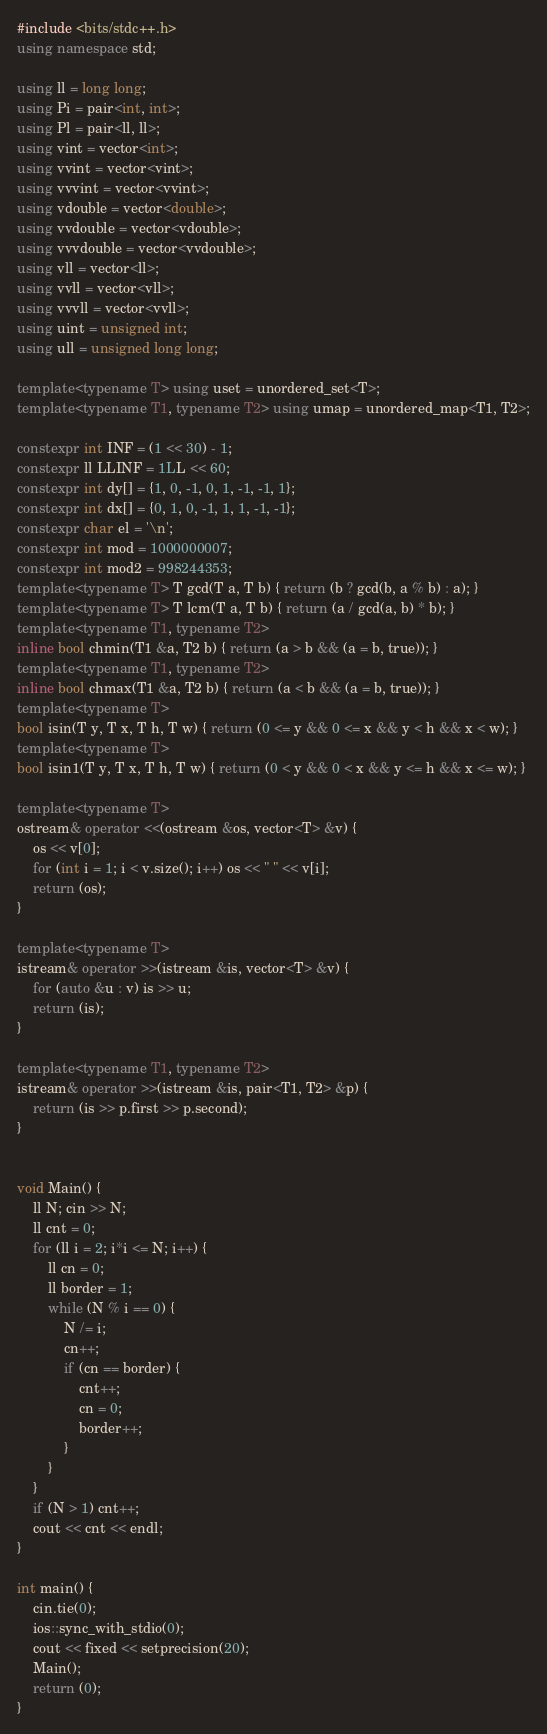<code> <loc_0><loc_0><loc_500><loc_500><_C++_>#include <bits/stdc++.h>
using namespace std;

using ll = long long;
using Pi = pair<int, int>;
using Pl = pair<ll, ll>;
using vint = vector<int>;
using vvint = vector<vint>;
using vvvint = vector<vvint>;
using vdouble = vector<double>;
using vvdouble = vector<vdouble>;
using vvvdouble = vector<vvdouble>;
using vll = vector<ll>;
using vvll = vector<vll>;
using vvvll = vector<vvll>;
using uint = unsigned int;
using ull = unsigned long long;

template<typename T> using uset = unordered_set<T>;
template<typename T1, typename T2> using umap = unordered_map<T1, T2>;

constexpr int INF = (1 << 30) - 1;
constexpr ll LLINF = 1LL << 60;
constexpr int dy[] = {1, 0, -1, 0, 1, -1, -1, 1};
constexpr int dx[] = {0, 1, 0, -1, 1, 1, -1, -1};
constexpr char el = '\n';
constexpr int mod = 1000000007;
constexpr int mod2 = 998244353;
template<typename T> T gcd(T a, T b) { return (b ? gcd(b, a % b) : a); }
template<typename T> T lcm(T a, T b) { return (a / gcd(a, b) * b); }
template<typename T1, typename T2>
inline bool chmin(T1 &a, T2 b) { return (a > b && (a = b, true)); }
template<typename T1, typename T2>
inline bool chmax(T1 &a, T2 b) { return (a < b && (a = b, true)); }
template<typename T>
bool isin(T y, T x, T h, T w) { return (0 <= y && 0 <= x && y < h && x < w); }
template<typename T>
bool isin1(T y, T x, T h, T w) { return (0 < y && 0 < x && y <= h && x <= w); }

template<typename T>
ostream& operator <<(ostream &os, vector<T> &v) {
	os << v[0];
	for (int i = 1; i < v.size(); i++) os << " " << v[i];
	return (os);
}

template<typename T>
istream& operator >>(istream &is, vector<T> &v) {
	for (auto &u : v) is >> u;
	return (is);
}

template<typename T1, typename T2>
istream& operator >>(istream &is, pair<T1, T2> &p) {
	return (is >> p.first >> p.second);
}


void Main() {
	ll N; cin >> N;
	ll cnt = 0;
	for (ll i = 2; i*i <= N; i++) {
		ll cn = 0;
		ll border = 1;
		while (N % i == 0) {
			N /= i;
			cn++;
			if (cn == border) {
				cnt++;
				cn = 0;
				border++;
			}
		}
	}
	if (N > 1) cnt++;
	cout << cnt << endl;
}

int main() {
	cin.tie(0);
	ios::sync_with_stdio(0);
	cout << fixed << setprecision(20);
	Main();
	return (0);
}
</code> 